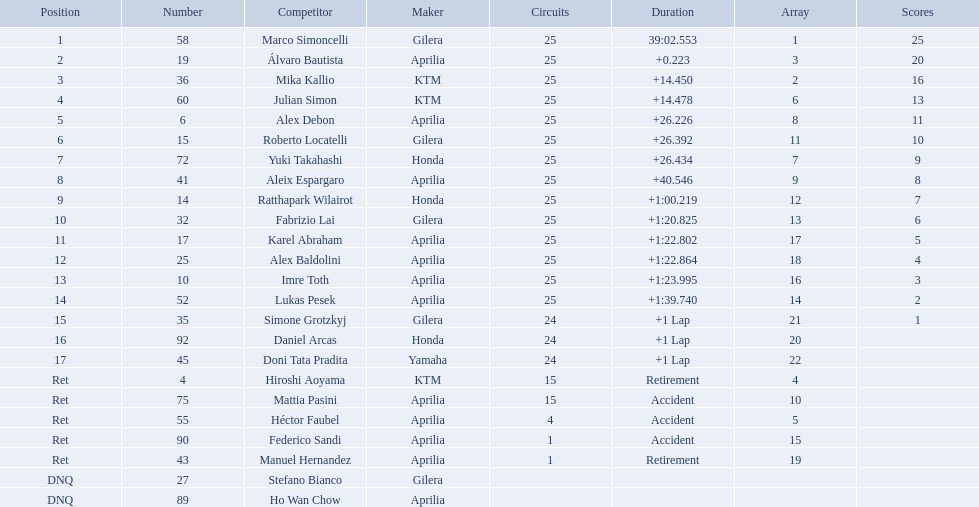How many laps did marco perform? 25. How many laps did hiroshi perform? 15. Which of these numbers are higher? 25. Who swam this number of laps? Marco Simoncelli. What player number is marked #1 for the australian motorcycle grand prix? 58. Who is the rider that represents the #58 in the australian motorcycle grand prix? Marco Simoncelli. Who are all the riders? Marco Simoncelli, Álvaro Bautista, Mika Kallio, Julian Simon, Alex Debon, Roberto Locatelli, Yuki Takahashi, Aleix Espargaro, Ratthapark Wilairot, Fabrizio Lai, Karel Abraham, Alex Baldolini, Imre Toth, Lukas Pesek, Simone Grotzkyj, Daniel Arcas, Doni Tata Pradita, Hiroshi Aoyama, Mattia Pasini, Héctor Faubel, Federico Sandi, Manuel Hernandez, Stefano Bianco, Ho Wan Chow. Which held rank 1? Marco Simoncelli. What was the fastest overall time? 39:02.553. Who does this time belong to? Marco Simoncelli. 